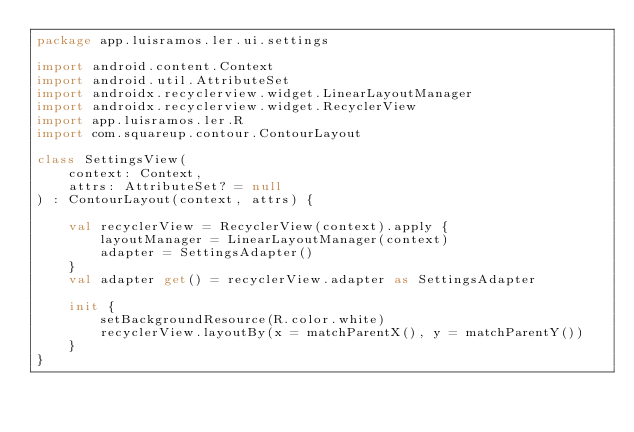Convert code to text. <code><loc_0><loc_0><loc_500><loc_500><_Kotlin_>package app.luisramos.ler.ui.settings

import android.content.Context
import android.util.AttributeSet
import androidx.recyclerview.widget.LinearLayoutManager
import androidx.recyclerview.widget.RecyclerView
import app.luisramos.ler.R
import com.squareup.contour.ContourLayout

class SettingsView(
    context: Context,
    attrs: AttributeSet? = null
) : ContourLayout(context, attrs) {

    val recyclerView = RecyclerView(context).apply {
        layoutManager = LinearLayoutManager(context)
        adapter = SettingsAdapter()
    }
    val adapter get() = recyclerView.adapter as SettingsAdapter

    init {
        setBackgroundResource(R.color.white)
        recyclerView.layoutBy(x = matchParentX(), y = matchParentY())
    }
}</code> 